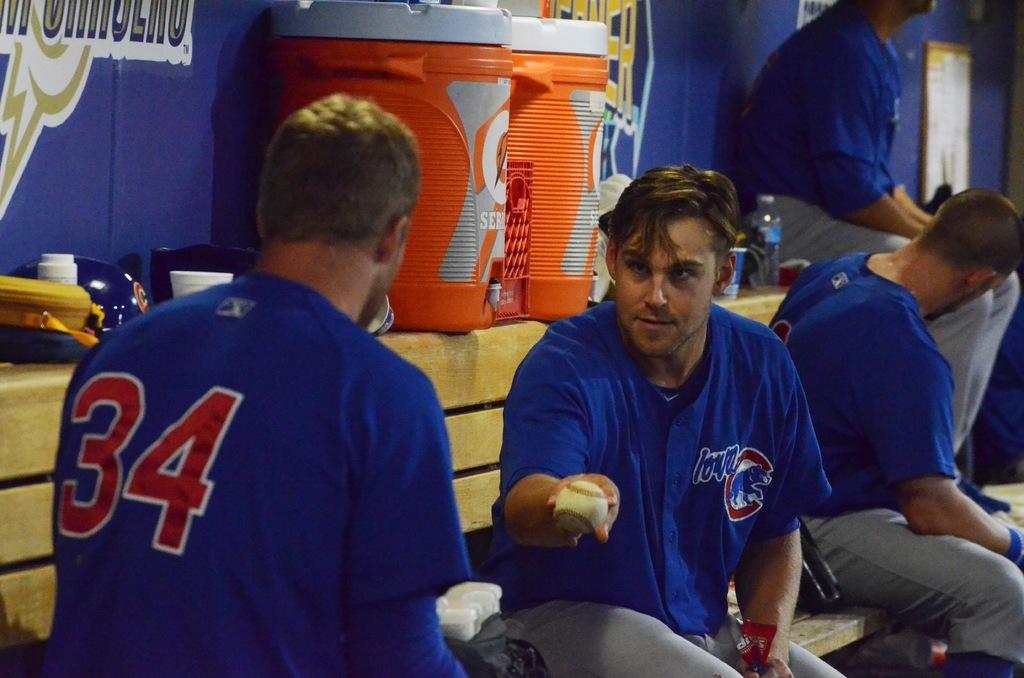What is the number of the player with his back to us?
Your answer should be compact. 34. 